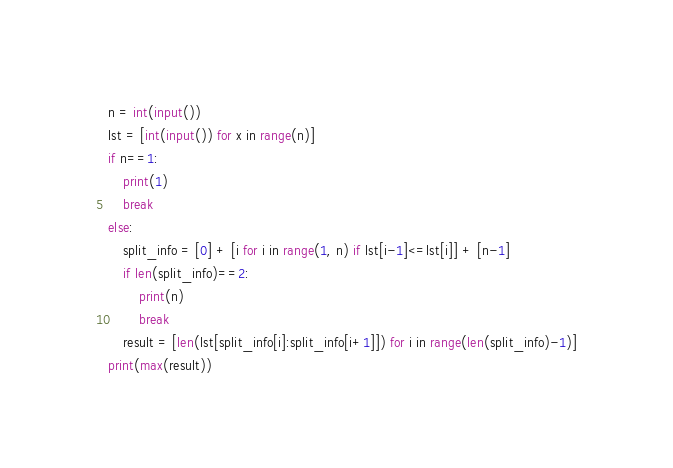<code> <loc_0><loc_0><loc_500><loc_500><_Python_>n = int(input())
lst = [int(input()) for x in range(n)]
if n==1:
    print(1)
    break
else:
    split_info = [0] + [i for i in range(1, n) if lst[i-1]<=lst[i]] + [n-1]
    if len(split_info)==2:
        print(n)
        break
    result = [len(lst[split_info[i]:split_info[i+1]]) for i in range(len(split_info)-1)]
print(max(result))</code> 